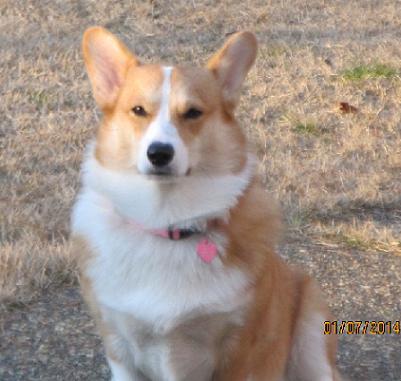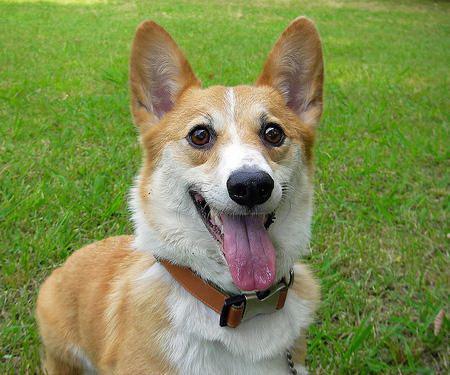The first image is the image on the left, the second image is the image on the right. Evaluate the accuracy of this statement regarding the images: "A dog is stationary with their tongue hanging out.". Is it true? Answer yes or no. Yes. The first image is the image on the left, the second image is the image on the right. For the images displayed, is the sentence "At least one dog is sitting." factually correct? Answer yes or no. Yes. 